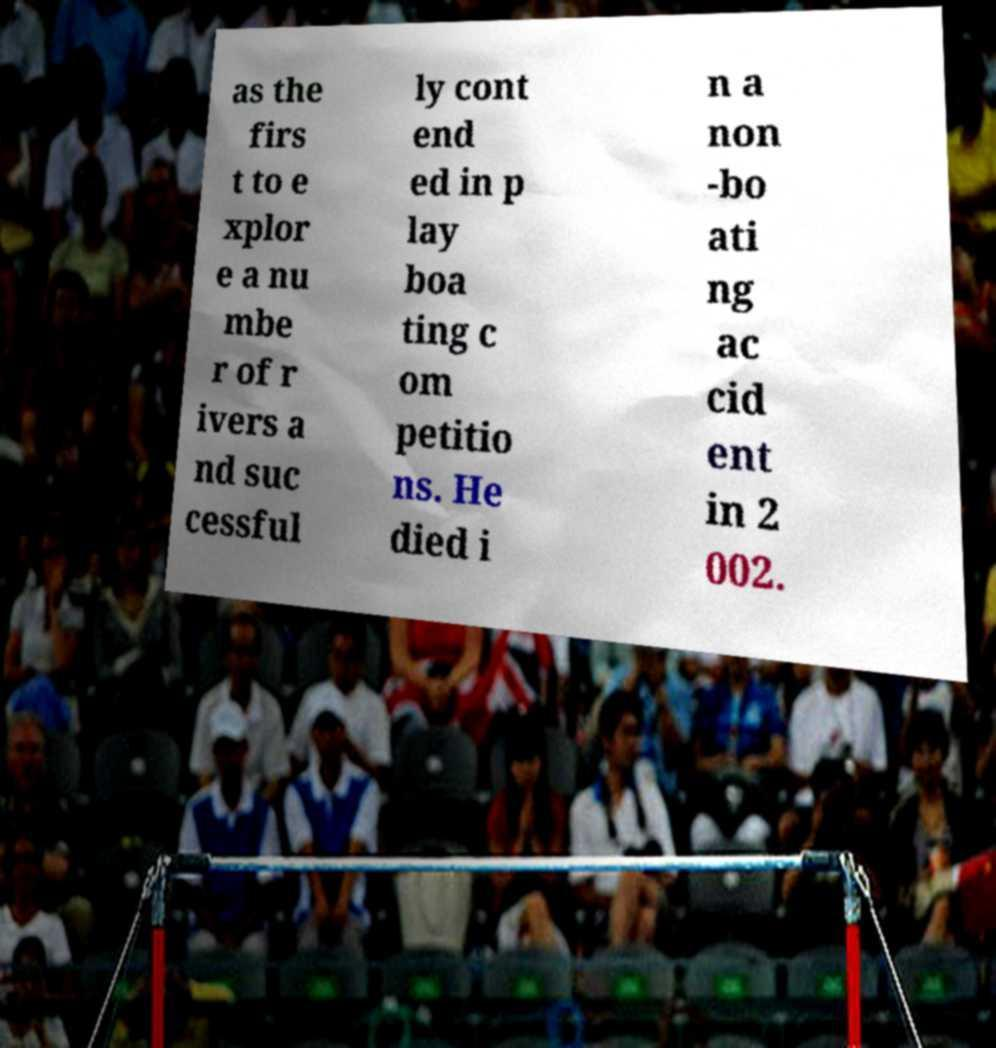Could you extract and type out the text from this image? as the firs t to e xplor e a nu mbe r of r ivers a nd suc cessful ly cont end ed in p lay boa ting c om petitio ns. He died i n a non -bo ati ng ac cid ent in 2 002. 